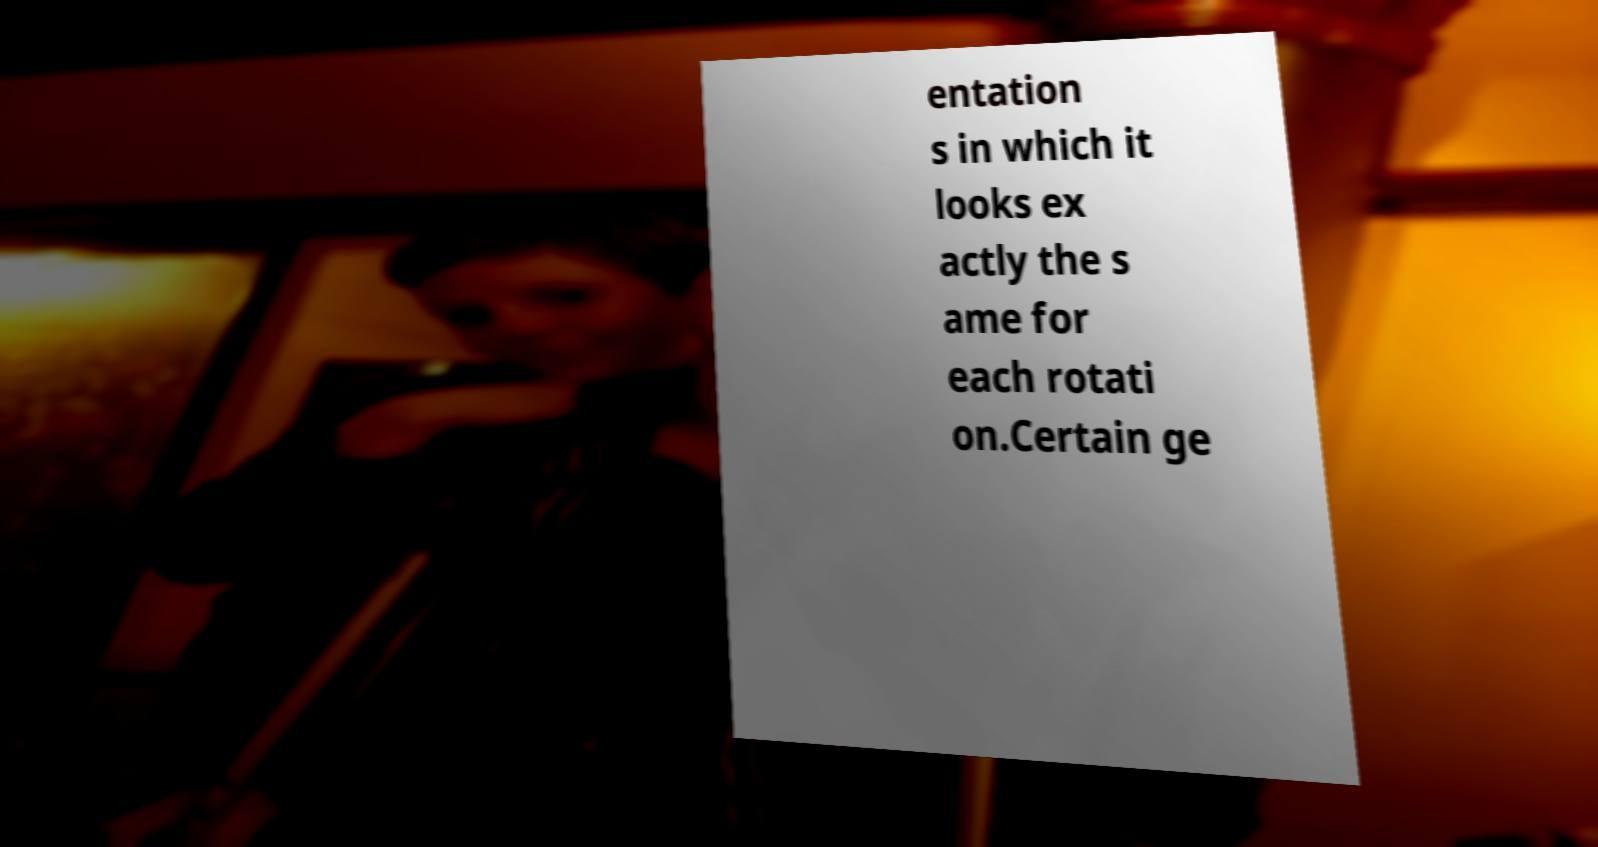There's text embedded in this image that I need extracted. Can you transcribe it verbatim? entation s in which it looks ex actly the s ame for each rotati on.Certain ge 